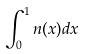Convert formula to latex. <formula><loc_0><loc_0><loc_500><loc_500>\int _ { 0 } ^ { 1 } n ( x ) d x</formula> 